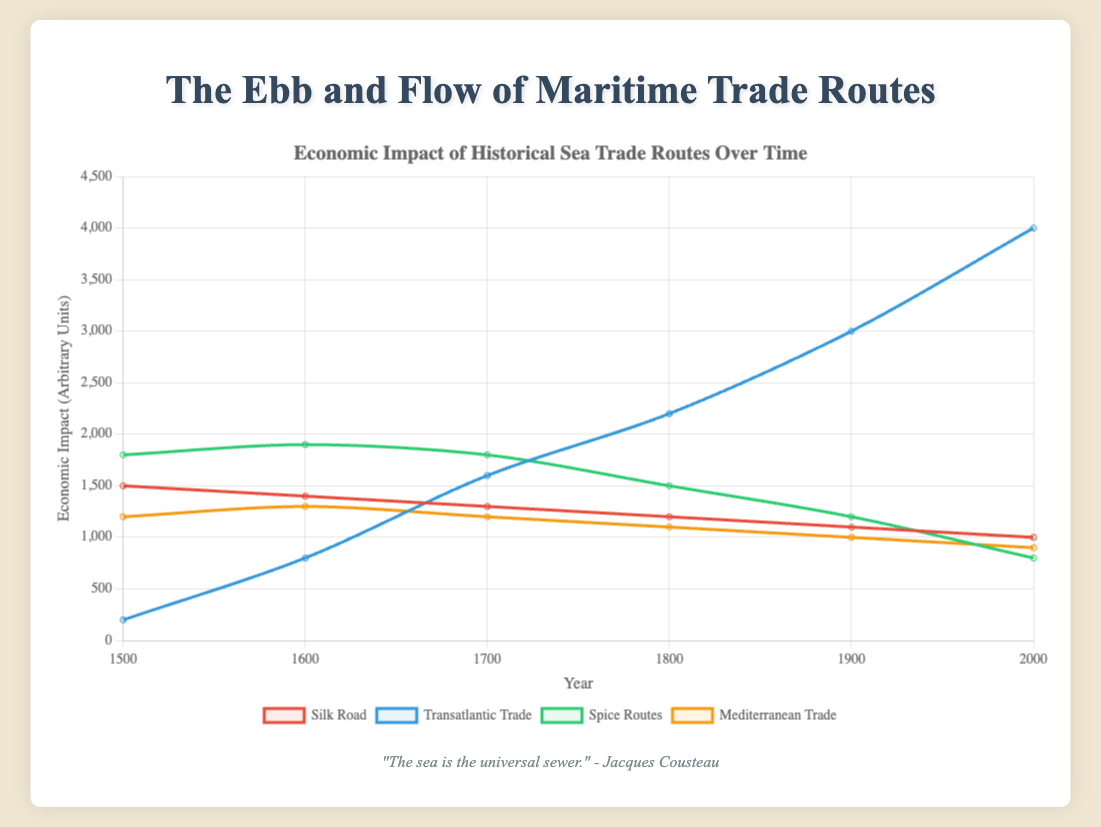Which trade route had the highest economic impact in 1500? Refer to the data for the year 1500; the Silk Road had an economic impact of 1500 units, Transatlantic Trade had 200 units, the Spice Routes had 1800 units, and Mediterranean Trade had 1200 units. Thus, the Spice Routes had the highest economic impact in 1500 with 1800 units.
Answer: Spice Routes Which route showed the most significant increase in economic impact from 1500 to 2000? To determine this, compare the difference between the economic impact in 1500 and 2000 for each route: Silk Road decreased by 500 units, Transatlantic Trade increased by 3800 units, Spice Routes decreased by 1000 units, and Mediterranean Trade decreased by 300 units. The Transatlantic Trade showed the most significant increase.
Answer: Transatlantic Trade What is the average economic impact of the Mediterranean Trade route across all years? To find the average, sum the values for each year and divide by the total number of years: (1200 + 1300 + 1200 + 1100 + 1000 + 900) / 6 = 6700 / 6 = 1116.67.
Answer: 1116.67 By how much did the economic impact of the Spice Routes change from 1600 to 1800? Find the difference between the values in 1600 and 1800: 1900 - 1500 = 400.
Answer: 400 Which trade route’s economic impact remained most stable over time? By visually comparing the trends in the data, observe that Mediterranean Trade shows the least fluctuation, indicating stability compared to others.
Answer: Mediterranean Trade Which year saw the largest economic impact for Transatlantic Trade? By examining the dataset, the highest value for Transatlantic Trade is in 2000 with 4000 units.
Answer: 2000 Compare the economic impacts of the Silk Road and Spice Routes in the year 1700. Which one is higher? In 1700, the Silk Road had an economic impact of 1300 units and the Spice Routes had 1800 units. Hence, the Spice Routes has the higher economic impact.
Answer: Spice Routes What is the total economic impact across all routes in the year 1600? Sum the economic impacts of all routes in 1600: 1400 (Silk Road) + 800 (Transatlantic Trade) + 1900 (Spice Routes) + 1300 (Mediterranean Trade) = 5400 units.
Answer: 5400 What are the differences in economic impact between Transatlantic Trade and Silk Road for the years 1500 and 1900? Calculate the differences: For 1500: 200 (Transatlantic Trade) - 1500 (Silk Road) = -1300. For 1900: 3000 (Transatlantic Trade) - 1100 (Silk Road) = 1900.
Answer: -1300 in 1500, 1900 in 1900 